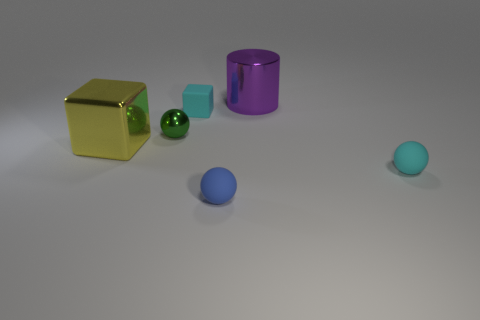Is there a object that is on the left side of the large metallic object on the right side of the small rubber cube?
Keep it short and to the point. Yes. What number of objects are objects right of the tiny shiny object or spheres that are left of the cyan block?
Offer a very short reply. 5. How many objects are either yellow matte cylinders or big purple cylinders to the right of the small green shiny sphere?
Your answer should be very brief. 1. How big is the metallic thing right of the matte object that is in front of the cyan rubber object that is in front of the small green metallic object?
Offer a very short reply. Large. There is a blue thing that is the same size as the matte cube; what is its material?
Your answer should be compact. Rubber. Is there a green metallic cube of the same size as the cylinder?
Offer a terse response. No. There is a thing to the left of the green sphere; does it have the same size as the purple metal object?
Ensure brevity in your answer.  Yes. What shape is the metal object that is behind the large yellow metal thing and to the left of the blue object?
Make the answer very short. Sphere. Are there more big metallic cubes that are left of the tiny cyan cube than small brown metal cylinders?
Offer a very short reply. Yes. The purple cylinder that is the same material as the tiny green ball is what size?
Give a very brief answer. Large. 